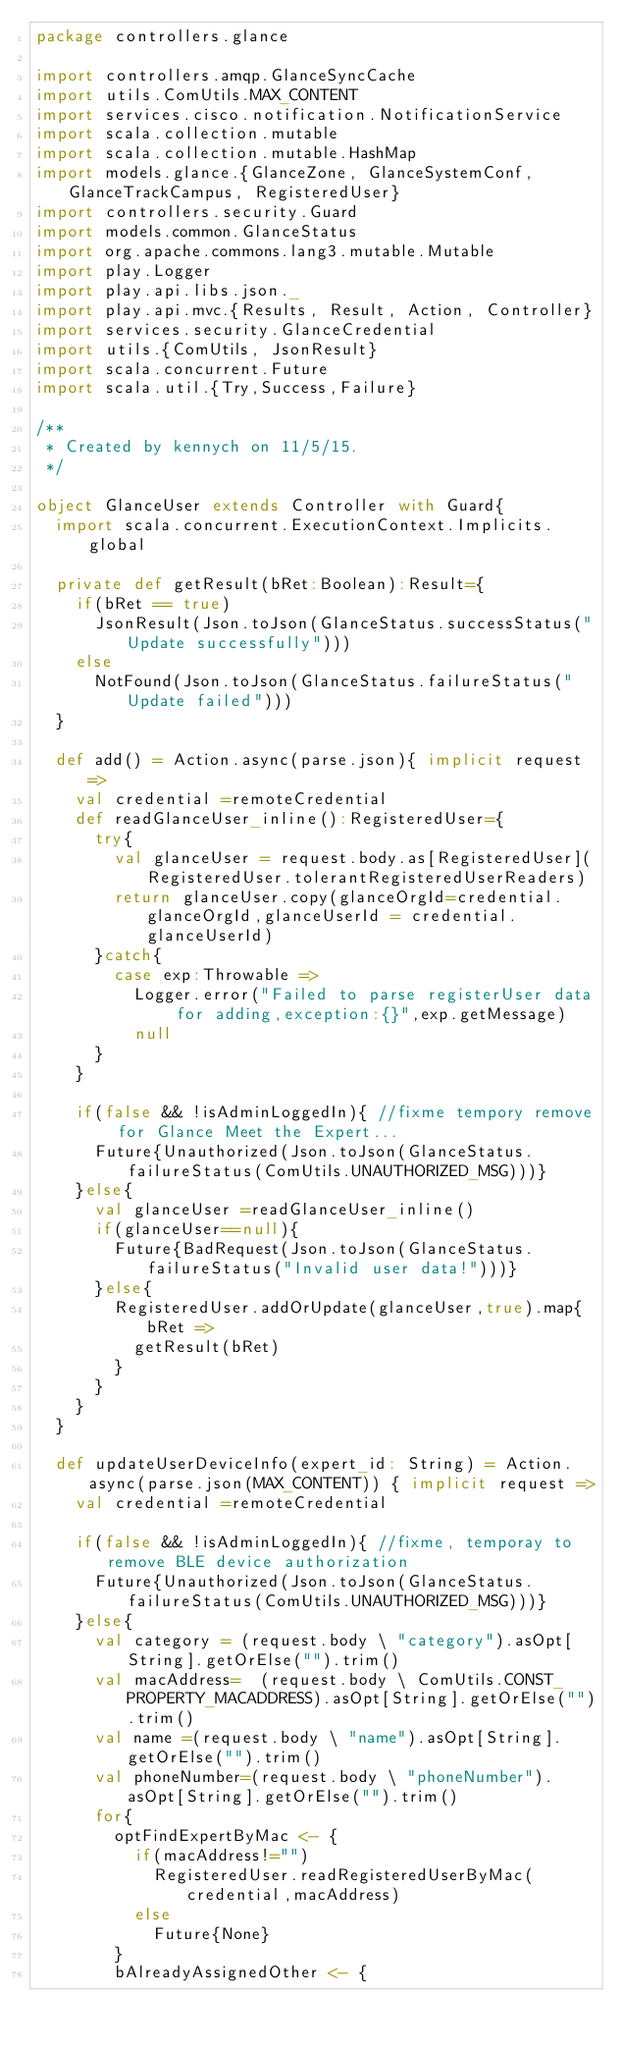<code> <loc_0><loc_0><loc_500><loc_500><_Scala_>package controllers.glance

import controllers.amqp.GlanceSyncCache
import utils.ComUtils.MAX_CONTENT
import services.cisco.notification.NotificationService
import scala.collection.mutable
import scala.collection.mutable.HashMap
import models.glance.{GlanceZone, GlanceSystemConf, GlanceTrackCampus, RegisteredUser}
import controllers.security.Guard
import models.common.GlanceStatus
import org.apache.commons.lang3.mutable.Mutable
import play.Logger
import play.api.libs.json._
import play.api.mvc.{Results, Result, Action, Controller}
import services.security.GlanceCredential
import utils.{ComUtils, JsonResult}
import scala.concurrent.Future
import scala.util.{Try,Success,Failure}

/**
 * Created by kennych on 11/5/15.
 */

object GlanceUser extends Controller with Guard{
  import scala.concurrent.ExecutionContext.Implicits.global

  private def getResult(bRet:Boolean):Result={
    if(bRet == true)
      JsonResult(Json.toJson(GlanceStatus.successStatus("Update successfully")))
    else
      NotFound(Json.toJson(GlanceStatus.failureStatus("Update failed")))
  }

  def add() = Action.async(parse.json){ implicit request =>
    val credential =remoteCredential
    def readGlanceUser_inline():RegisteredUser={
      try{
        val glanceUser = request.body.as[RegisteredUser](RegisteredUser.tolerantRegisteredUserReaders)
        return glanceUser.copy(glanceOrgId=credential.glanceOrgId,glanceUserId = credential.glanceUserId)
      }catch{
        case exp:Throwable =>
          Logger.error("Failed to parse registerUser data for adding,exception:{}",exp.getMessage)
          null
      }
    }

    if(false && !isAdminLoggedIn){ //fixme tempory remove for Glance Meet the Expert...
      Future{Unauthorized(Json.toJson(GlanceStatus.failureStatus(ComUtils.UNAUTHORIZED_MSG)))}
    }else{
      val glanceUser =readGlanceUser_inline()
      if(glanceUser==null){
        Future{BadRequest(Json.toJson(GlanceStatus.failureStatus("Invalid user data!")))}
      }else{
        RegisteredUser.addOrUpdate(glanceUser,true).map{ bRet =>
          getResult(bRet)
        }
      }
    }
  }

  def updateUserDeviceInfo(expert_id: String) = Action.async(parse.json(MAX_CONTENT)) { implicit request =>
    val credential =remoteCredential

    if(false && !isAdminLoggedIn){ //fixme, temporay to remove BLE device authorization
      Future{Unauthorized(Json.toJson(GlanceStatus.failureStatus(ComUtils.UNAUTHORIZED_MSG)))}
    }else{
      val category = (request.body \ "category").asOpt[String].getOrElse("").trim()
      val macAddress=  (request.body \ ComUtils.CONST_PROPERTY_MACADDRESS).asOpt[String].getOrElse("").trim()
      val name =(request.body \ "name").asOpt[String].getOrElse("").trim()
      val phoneNumber=(request.body \ "phoneNumber").asOpt[String].getOrElse("").trim()
      for{
        optFindExpertByMac <- {
          if(macAddress!="")
            RegisteredUser.readRegisteredUserByMac(credential,macAddress)
          else
            Future{None}
        }
        bAlreadyAssignedOther <- {</code> 